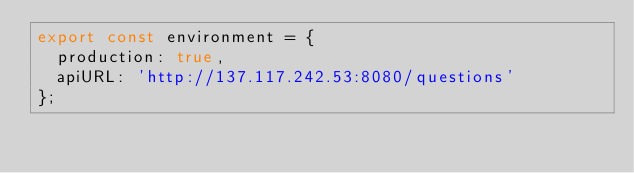Convert code to text. <code><loc_0><loc_0><loc_500><loc_500><_TypeScript_>export const environment = {
  production: true,
  apiURL: 'http://137.117.242.53:8080/questions'
};
</code> 